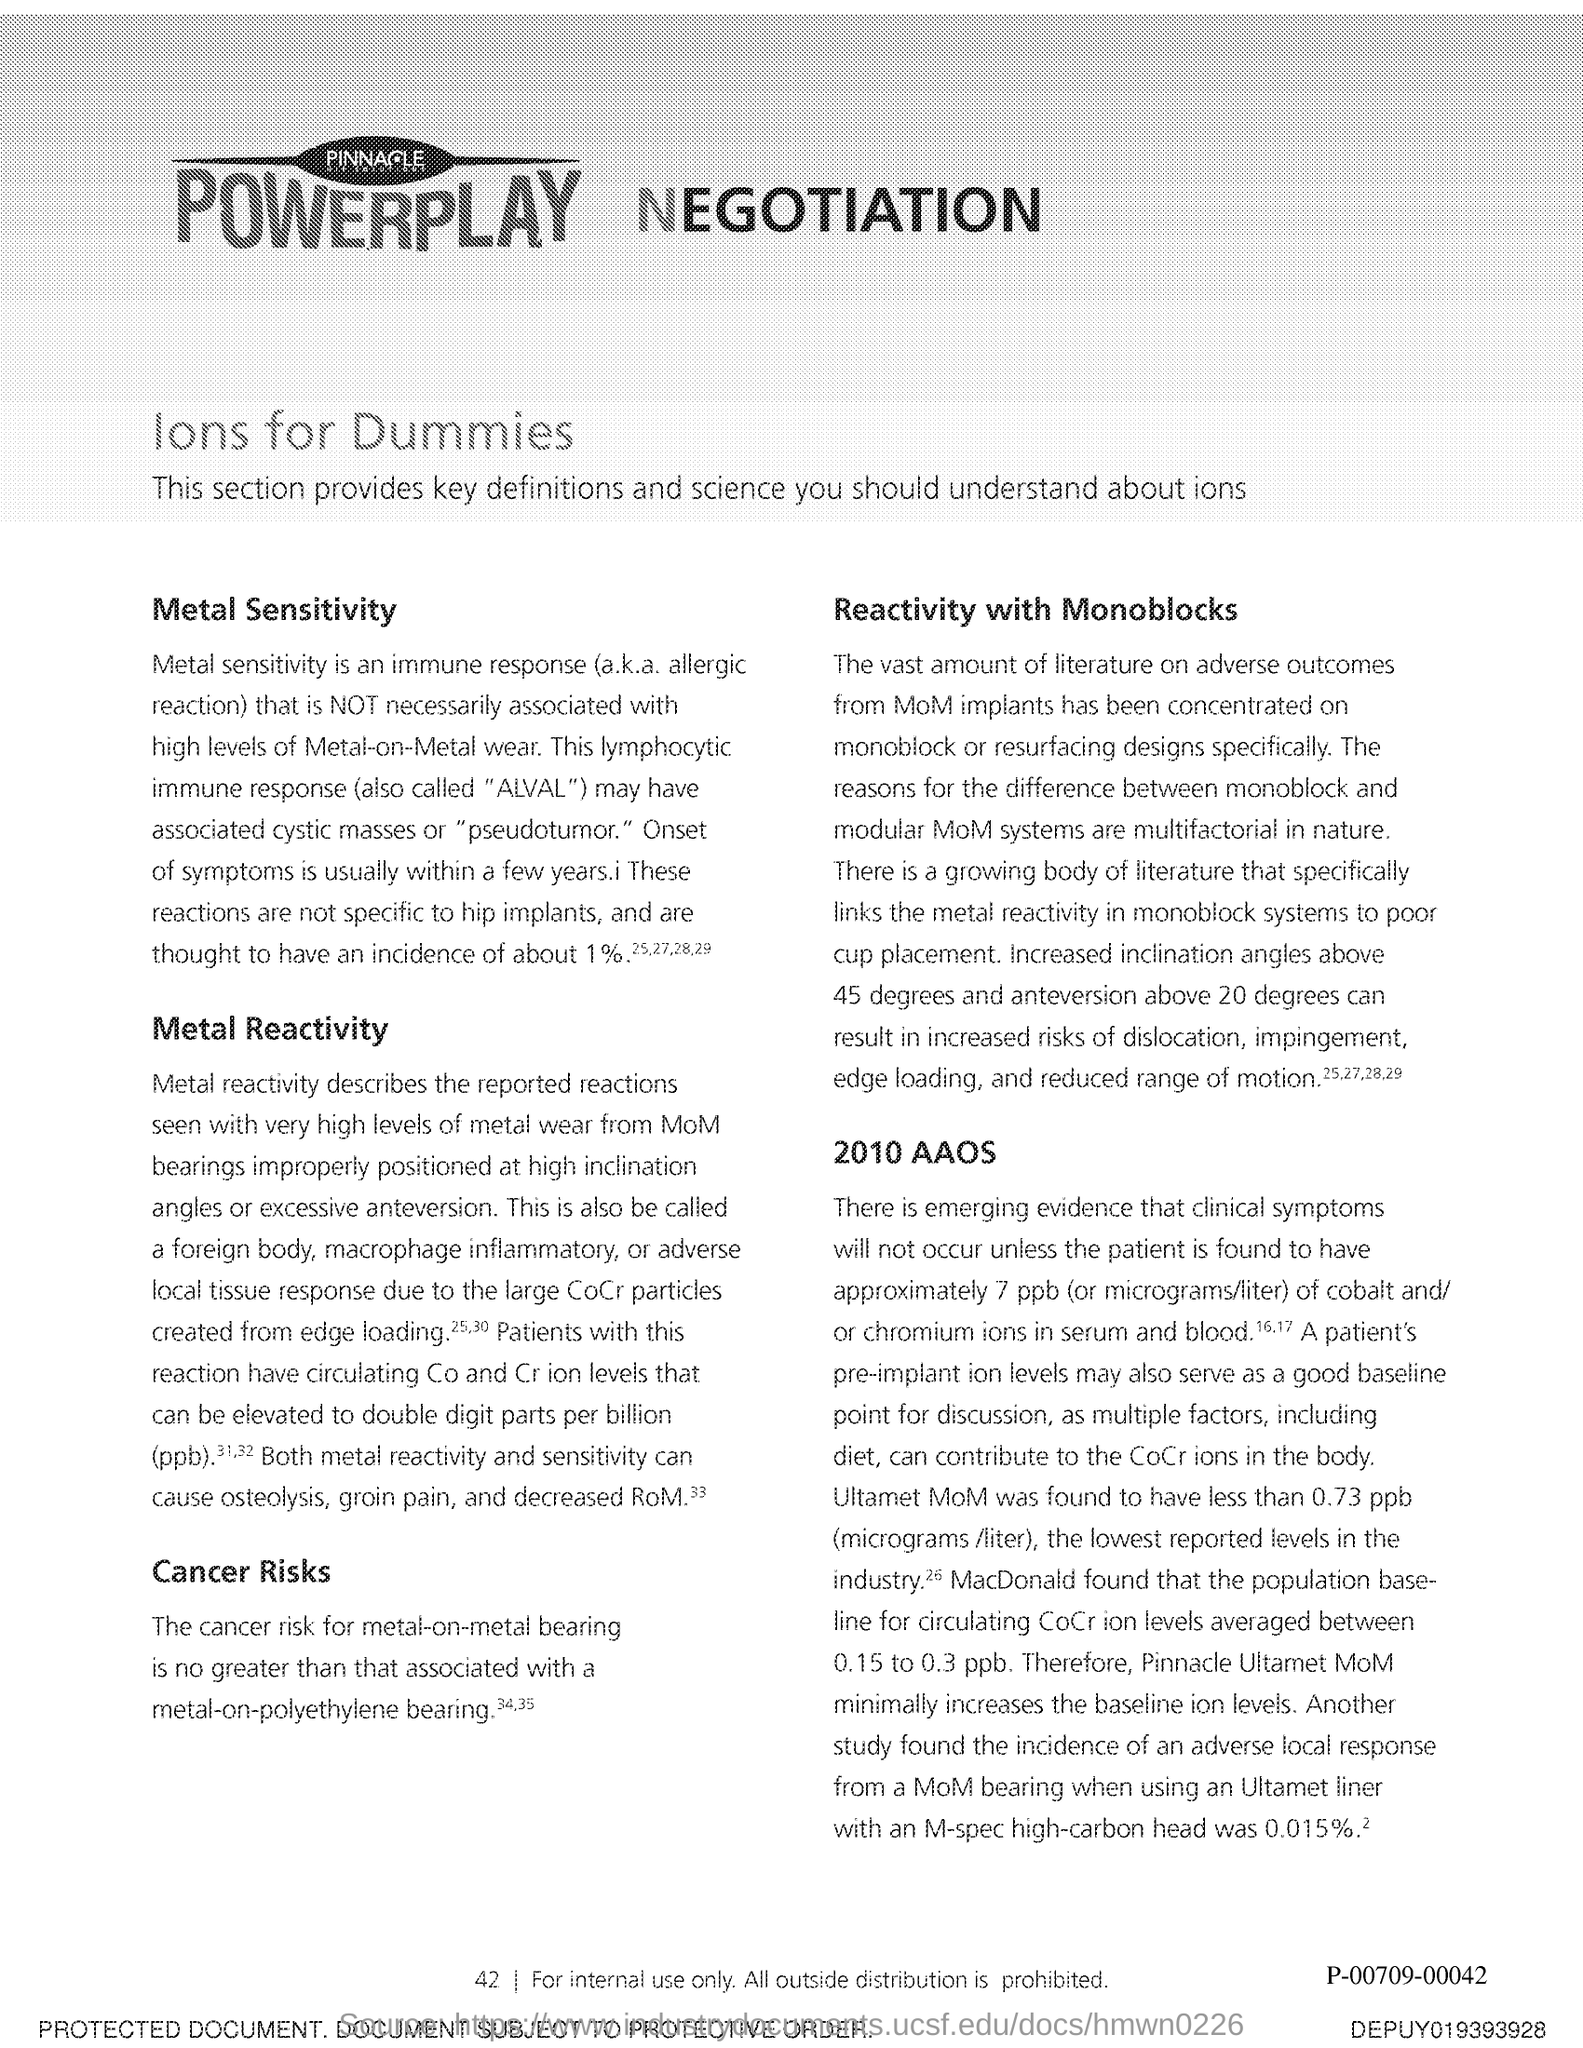What is the page number?
Make the answer very short. 42. 